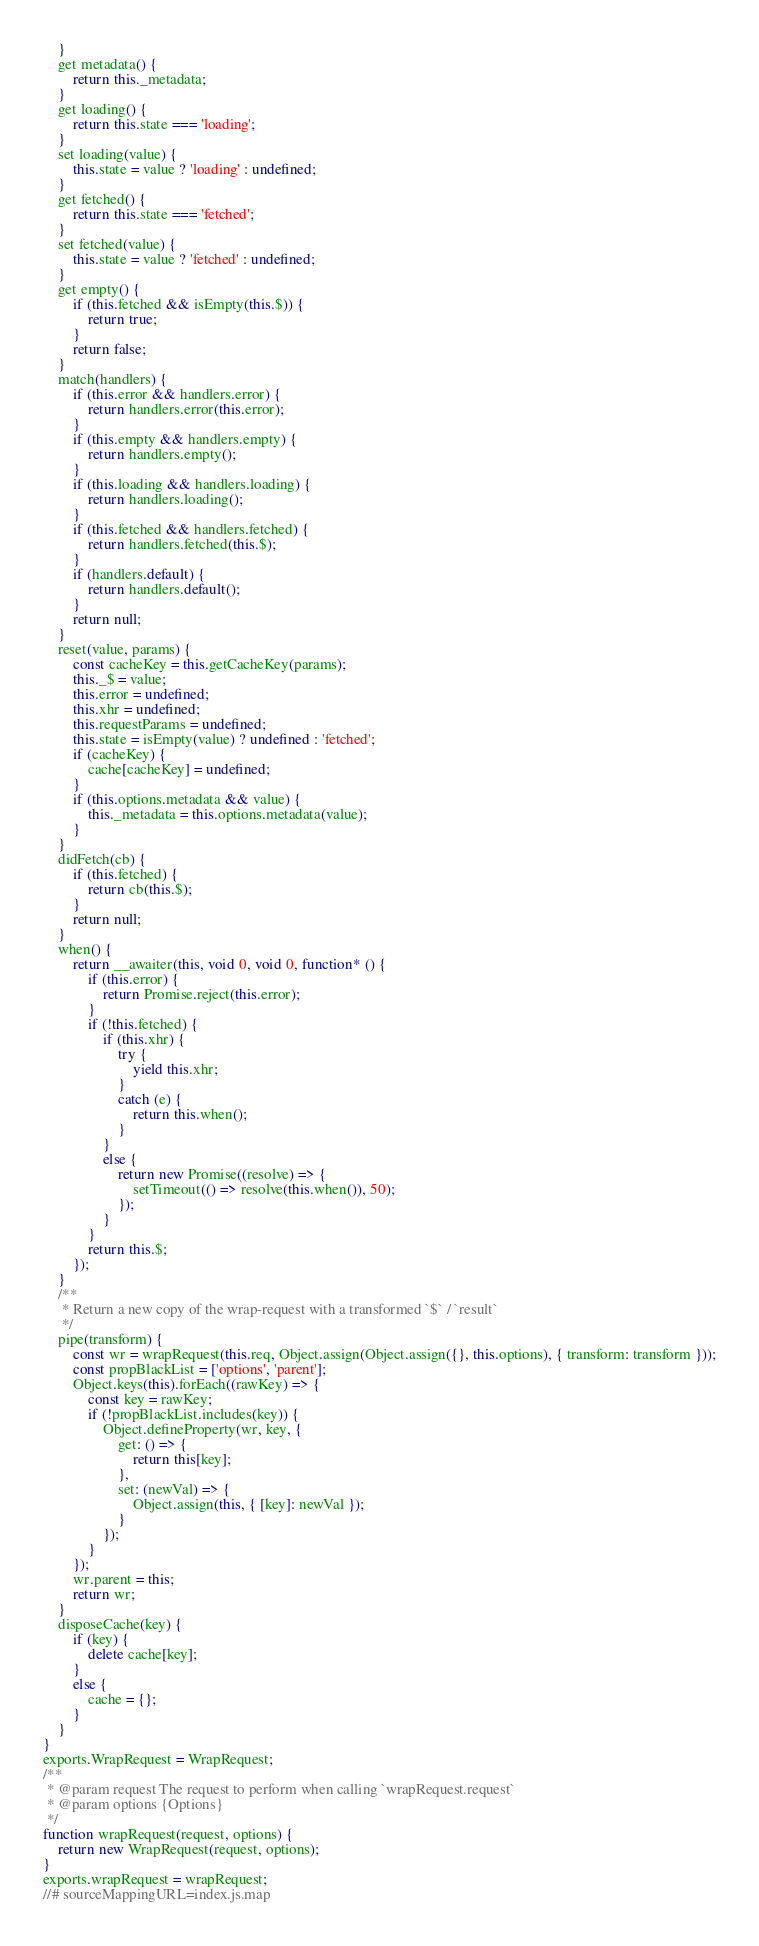Convert code to text. <code><loc_0><loc_0><loc_500><loc_500><_JavaScript_>    }
    get metadata() {
        return this._metadata;
    }
    get loading() {
        return this.state === 'loading';
    }
    set loading(value) {
        this.state = value ? 'loading' : undefined;
    }
    get fetched() {
        return this.state === 'fetched';
    }
    set fetched(value) {
        this.state = value ? 'fetched' : undefined;
    }
    get empty() {
        if (this.fetched && isEmpty(this.$)) {
            return true;
        }
        return false;
    }
    match(handlers) {
        if (this.error && handlers.error) {
            return handlers.error(this.error);
        }
        if (this.empty && handlers.empty) {
            return handlers.empty();
        }
        if (this.loading && handlers.loading) {
            return handlers.loading();
        }
        if (this.fetched && handlers.fetched) {
            return handlers.fetched(this.$);
        }
        if (handlers.default) {
            return handlers.default();
        }
        return null;
    }
    reset(value, params) {
        const cacheKey = this.getCacheKey(params);
        this._$ = value;
        this.error = undefined;
        this.xhr = undefined;
        this.requestParams = undefined;
        this.state = isEmpty(value) ? undefined : 'fetched';
        if (cacheKey) {
            cache[cacheKey] = undefined;
        }
        if (this.options.metadata && value) {
            this._metadata = this.options.metadata(value);
        }
    }
    didFetch(cb) {
        if (this.fetched) {
            return cb(this.$);
        }
        return null;
    }
    when() {
        return __awaiter(this, void 0, void 0, function* () {
            if (this.error) {
                return Promise.reject(this.error);
            }
            if (!this.fetched) {
                if (this.xhr) {
                    try {
                        yield this.xhr;
                    }
                    catch (e) {
                        return this.when();
                    }
                }
                else {
                    return new Promise((resolve) => {
                        setTimeout(() => resolve(this.when()), 50);
                    });
                }
            }
            return this.$;
        });
    }
    /**
     * Return a new copy of the wrap-request with a transformed `$` / `result`
     */
    pipe(transform) {
        const wr = wrapRequest(this.req, Object.assign(Object.assign({}, this.options), { transform: transform }));
        const propBlackList = ['options', 'parent'];
        Object.keys(this).forEach((rawKey) => {
            const key = rawKey;
            if (!propBlackList.includes(key)) {
                Object.defineProperty(wr, key, {
                    get: () => {
                        return this[key];
                    },
                    set: (newVal) => {
                        Object.assign(this, { [key]: newVal });
                    }
                });
            }
        });
        wr.parent = this;
        return wr;
    }
    disposeCache(key) {
        if (key) {
            delete cache[key];
        }
        else {
            cache = {};
        }
    }
}
exports.WrapRequest = WrapRequest;
/**
 * @param request The request to perform when calling `wrapRequest.request`
 * @param options {Options}
 */
function wrapRequest(request, options) {
    return new WrapRequest(request, options);
}
exports.wrapRequest = wrapRequest;
//# sourceMappingURL=index.js.map</code> 